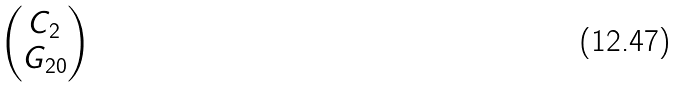Convert formula to latex. <formula><loc_0><loc_0><loc_500><loc_500>\begin{pmatrix} C _ { 2 } \\ G _ { 2 0 } \end{pmatrix}</formula> 